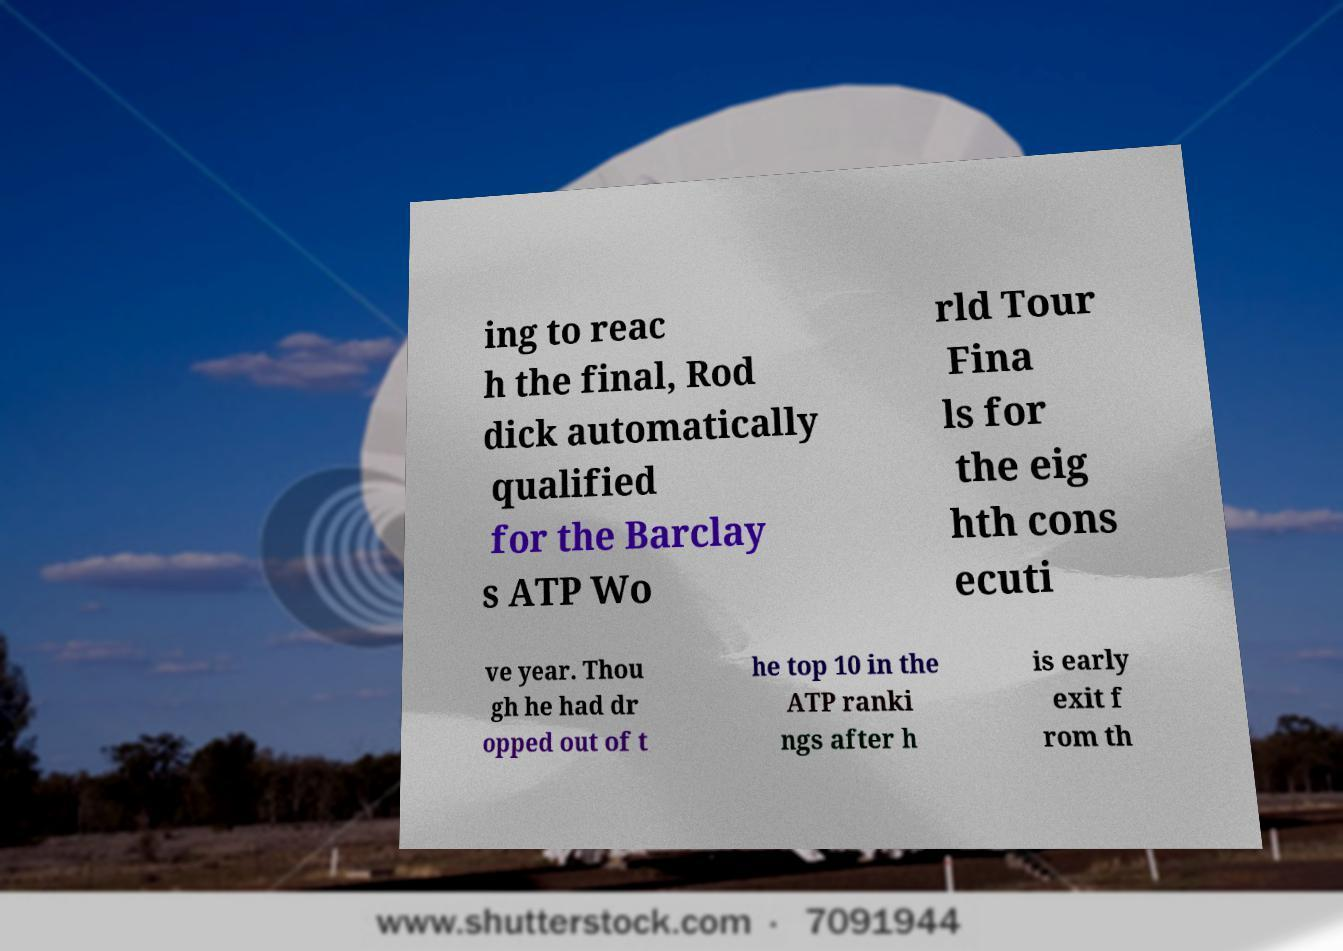Please read and relay the text visible in this image. What does it say? ing to reac h the final, Rod dick automatically qualified for the Barclay s ATP Wo rld Tour Fina ls for the eig hth cons ecuti ve year. Thou gh he had dr opped out of t he top 10 in the ATP ranki ngs after h is early exit f rom th 